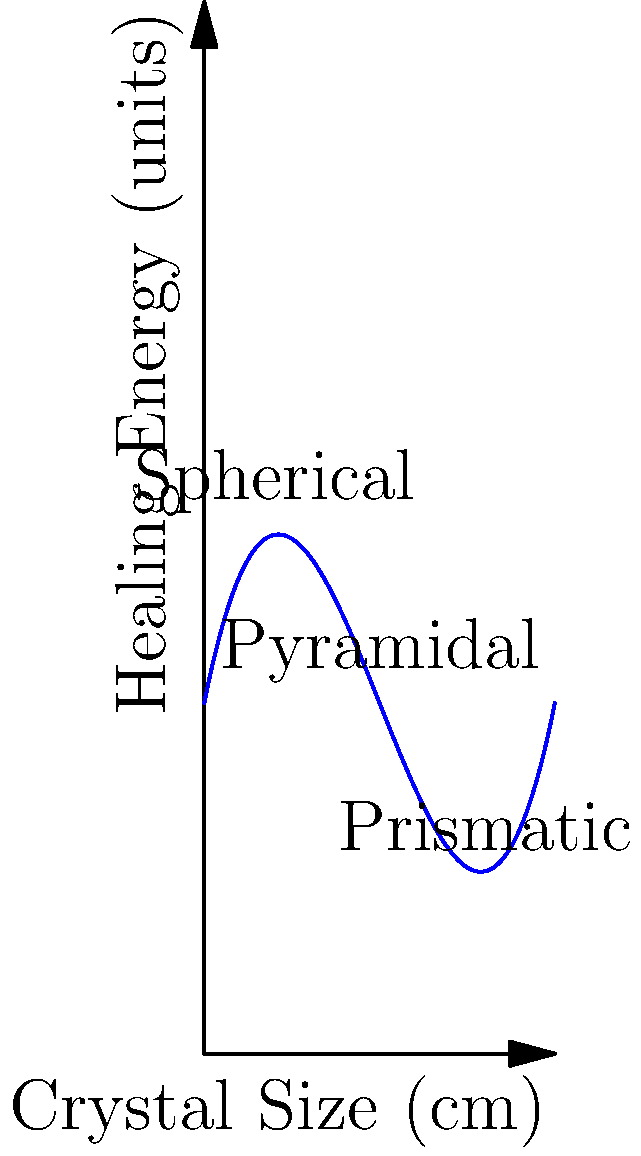The graph represents the relationship between crystal size and healing energy for different crystal shapes. The function $f(x) = 0.1x^3 - 1.5x^2 + 5x + 10$ models this relationship, where $x$ is the crystal size in centimeters and $f(x)$ is the healing energy in units. At what crystal size does the pyramidal shape exhibit its maximum healing energy? To find the crystal size where the pyramidal shape exhibits maximum healing energy, we need to:

1. Find the derivative of the function: $f'(x) = 0.3x^2 - 3x + 5$

2. Set the derivative to zero and solve for x:
   $0.3x^2 - 3x + 5 = 0$

3. This is a quadratic equation. We can solve it using the quadratic formula:
   $x = \frac{-b \pm \sqrt{b^2 - 4ac}}{2a}$

   Where $a = 0.3$, $b = -3$, and $c = 5$

4. Plugging in these values:
   $x = \frac{3 \pm \sqrt{9 - 6}}{0.6} = \frac{3 \pm \sqrt{3}}{0.6}$

5. This gives us two solutions:
   $x_1 = \frac{3 + \sqrt{3}}{0.6} \approx 6.88$ cm
   $x_2 = \frac{3 - \sqrt{3}}{0.6} \approx 3.12$ cm

6. The question asks about the pyramidal shape, which is represented at x = 5 cm on the graph.

7. The maximum point closest to 5 cm is $x_1 \approx 6.88$ cm.

Therefore, the pyramidal shape exhibits its maximum healing energy at approximately 6.88 cm.
Answer: 6.88 cm 